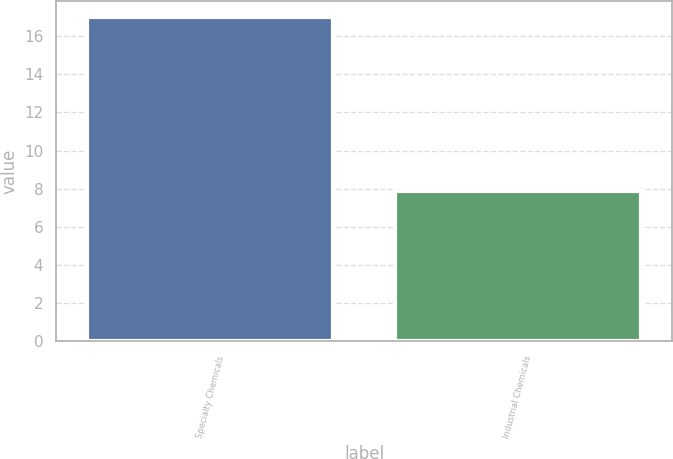<chart> <loc_0><loc_0><loc_500><loc_500><bar_chart><fcel>Specialty Chemicals<fcel>Industrial Chemicals<nl><fcel>17<fcel>7.9<nl></chart> 